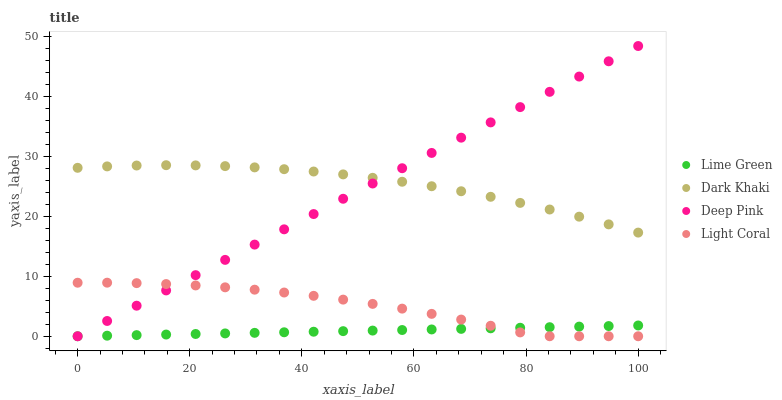Does Lime Green have the minimum area under the curve?
Answer yes or no. Yes. Does Dark Khaki have the maximum area under the curve?
Answer yes or no. Yes. Does Light Coral have the minimum area under the curve?
Answer yes or no. No. Does Light Coral have the maximum area under the curve?
Answer yes or no. No. Is Lime Green the smoothest?
Answer yes or no. Yes. Is Light Coral the roughest?
Answer yes or no. Yes. Is Deep Pink the smoothest?
Answer yes or no. No. Is Deep Pink the roughest?
Answer yes or no. No. Does Light Coral have the lowest value?
Answer yes or no. Yes. Does Deep Pink have the highest value?
Answer yes or no. Yes. Does Light Coral have the highest value?
Answer yes or no. No. Is Light Coral less than Dark Khaki?
Answer yes or no. Yes. Is Dark Khaki greater than Lime Green?
Answer yes or no. Yes. Does Lime Green intersect Light Coral?
Answer yes or no. Yes. Is Lime Green less than Light Coral?
Answer yes or no. No. Is Lime Green greater than Light Coral?
Answer yes or no. No. Does Light Coral intersect Dark Khaki?
Answer yes or no. No. 